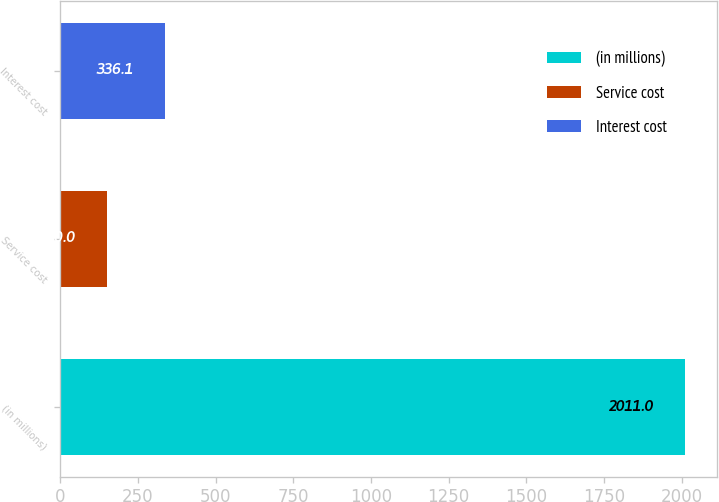Convert chart. <chart><loc_0><loc_0><loc_500><loc_500><bar_chart><fcel>(in millions)<fcel>Service cost<fcel>Interest cost<nl><fcel>2011<fcel>150<fcel>336.1<nl></chart> 